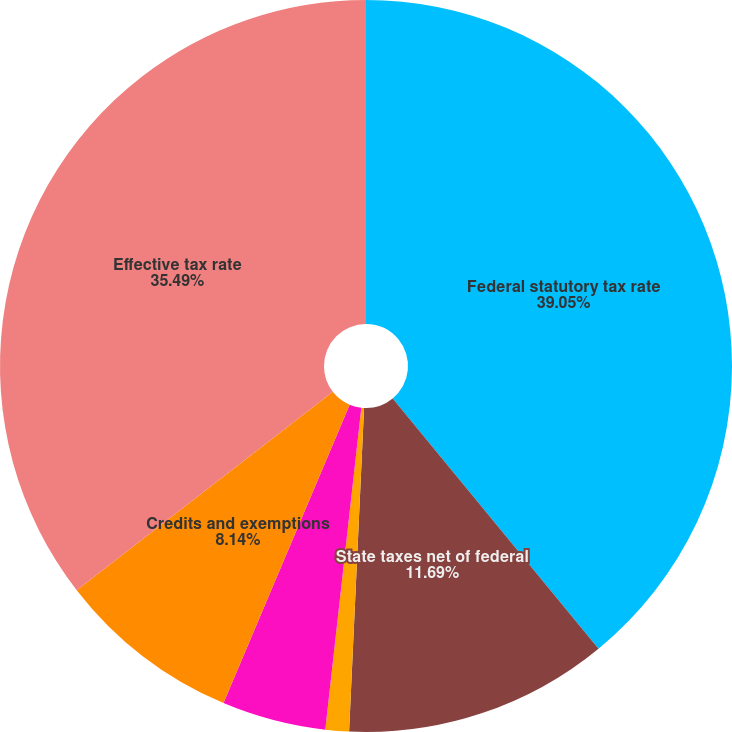<chart> <loc_0><loc_0><loc_500><loc_500><pie_chart><fcel>Federal statutory tax rate<fcel>State taxes net of federal<fcel>Non-deductible expenses<fcel>Change in valuation allowance<fcel>Credits and exemptions<fcel>Effective tax rate<nl><fcel>39.04%<fcel>11.69%<fcel>1.04%<fcel>4.59%<fcel>8.14%<fcel>35.49%<nl></chart> 